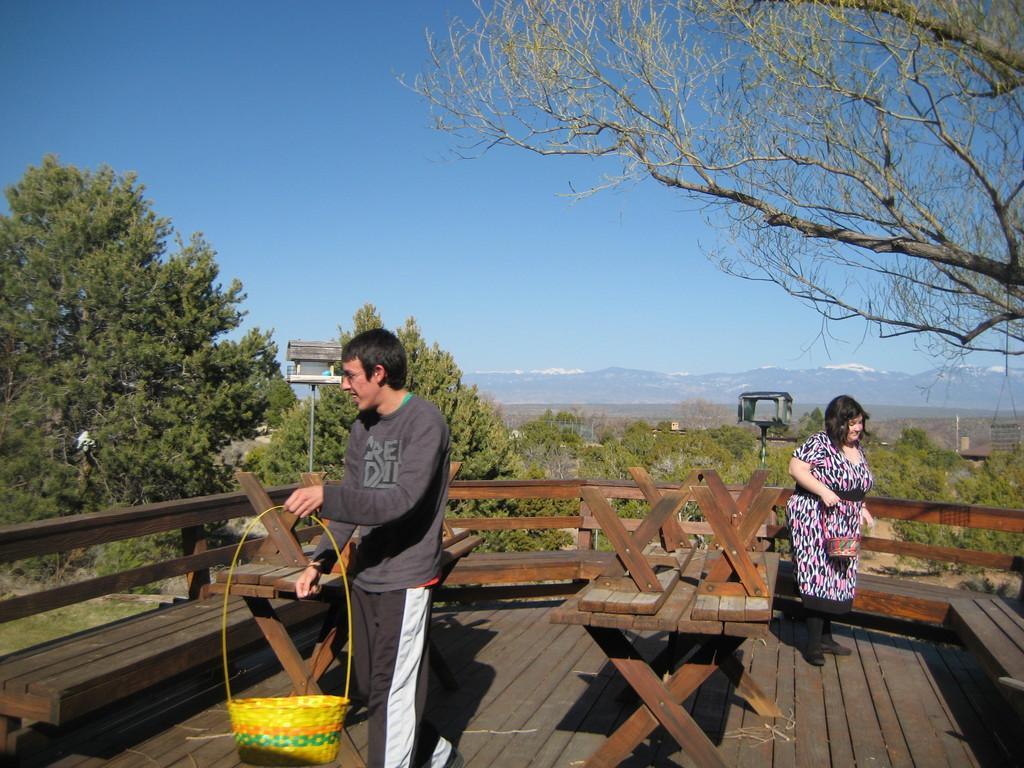Can you describe this image briefly? These two persons are standing and holding basket. We can see bench and floor. On the background we can see trees,sky. 